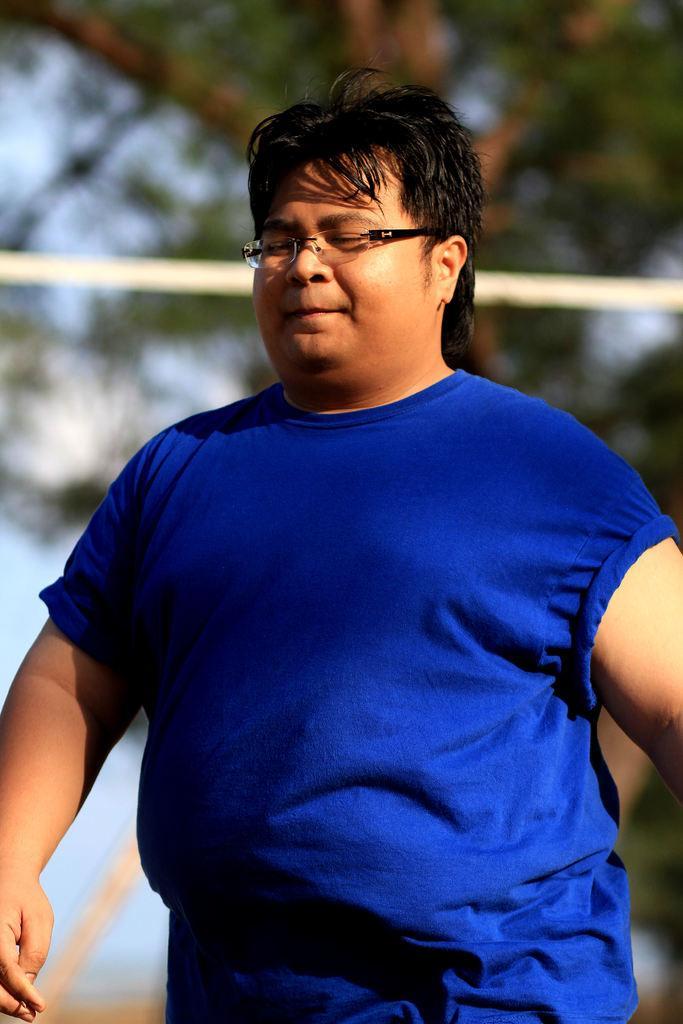Describe this image in one or two sentences. In this image we can see a man wearing a blue shirt. In the background there is a tree and sky. 